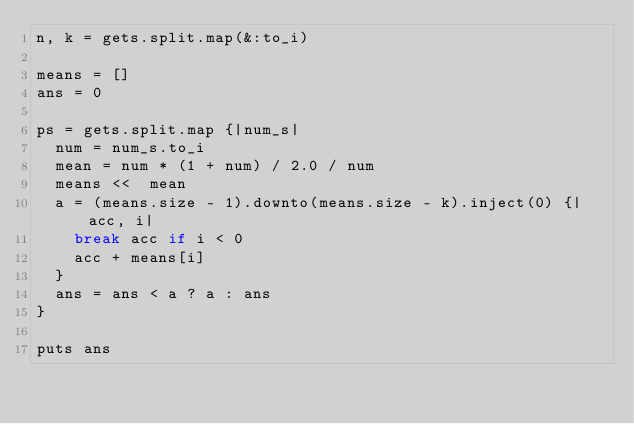Convert code to text. <code><loc_0><loc_0><loc_500><loc_500><_Ruby_>n, k = gets.split.map(&:to_i)

means = []
ans = 0

ps = gets.split.map {|num_s|
  num = num_s.to_i
  mean = num * (1 + num) / 2.0 / num
  means <<  mean
  a = (means.size - 1).downto(means.size - k).inject(0) {|acc, i|
    break acc if i < 0
    acc + means[i]
  }
  ans = ans < a ? a : ans 
}

puts ans
</code> 